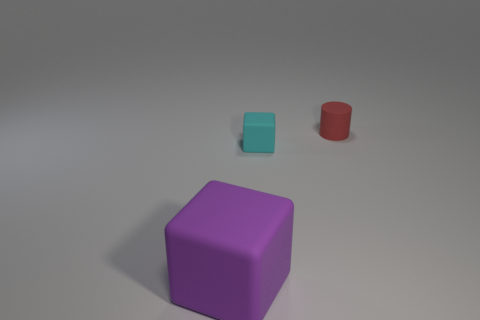Add 2 metallic things. How many objects exist? 5 Subtract all cubes. How many objects are left? 1 Add 2 small red rubber things. How many small red rubber things exist? 3 Subtract 0 purple spheres. How many objects are left? 3 Subtract all tiny yellow metallic cylinders. Subtract all cyan matte blocks. How many objects are left? 2 Add 3 red objects. How many red objects are left? 4 